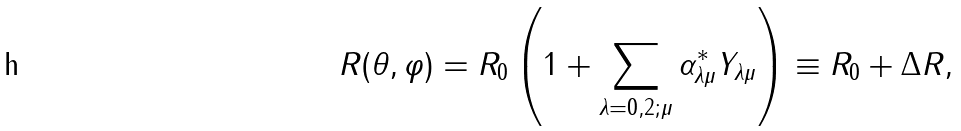Convert formula to latex. <formula><loc_0><loc_0><loc_500><loc_500>R ( \theta , \varphi ) = R _ { 0 } \left ( 1 + \sum _ { \lambda = 0 , 2 ; \mu } \alpha _ { \lambda \mu } ^ { * } Y _ { \lambda \mu } \right ) \equiv R _ { 0 } + \Delta R ,</formula> 